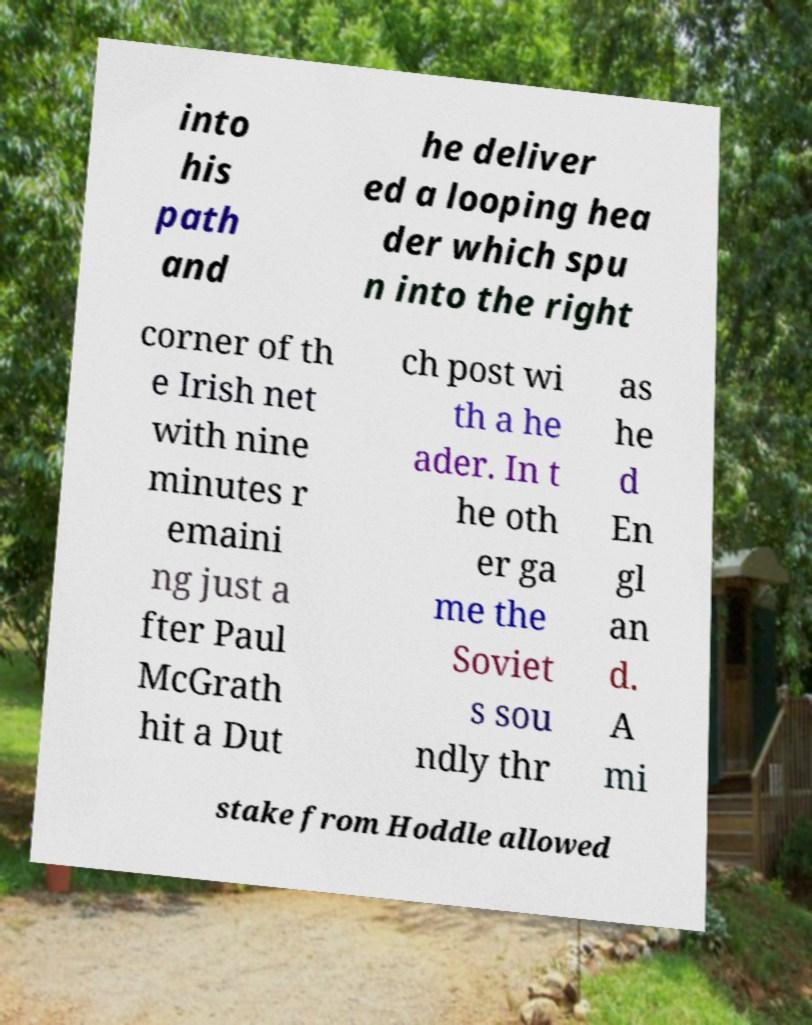What messages or text are displayed in this image? I need them in a readable, typed format. into his path and he deliver ed a looping hea der which spu n into the right corner of th e Irish net with nine minutes r emaini ng just a fter Paul McGrath hit a Dut ch post wi th a he ader. In t he oth er ga me the Soviet s sou ndly thr as he d En gl an d. A mi stake from Hoddle allowed 